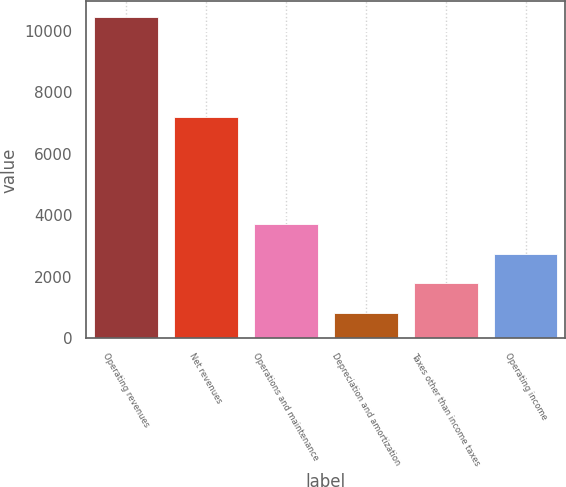<chart> <loc_0><loc_0><loc_500><loc_500><bar_chart><fcel>Operating revenues<fcel>Net revenues<fcel>Operations and maintenance<fcel>Depreciation and amortization<fcel>Taxes other than income taxes<fcel>Operating income<nl><fcel>10432<fcel>7189<fcel>3709.9<fcel>829<fcel>1789.3<fcel>2749.6<nl></chart> 